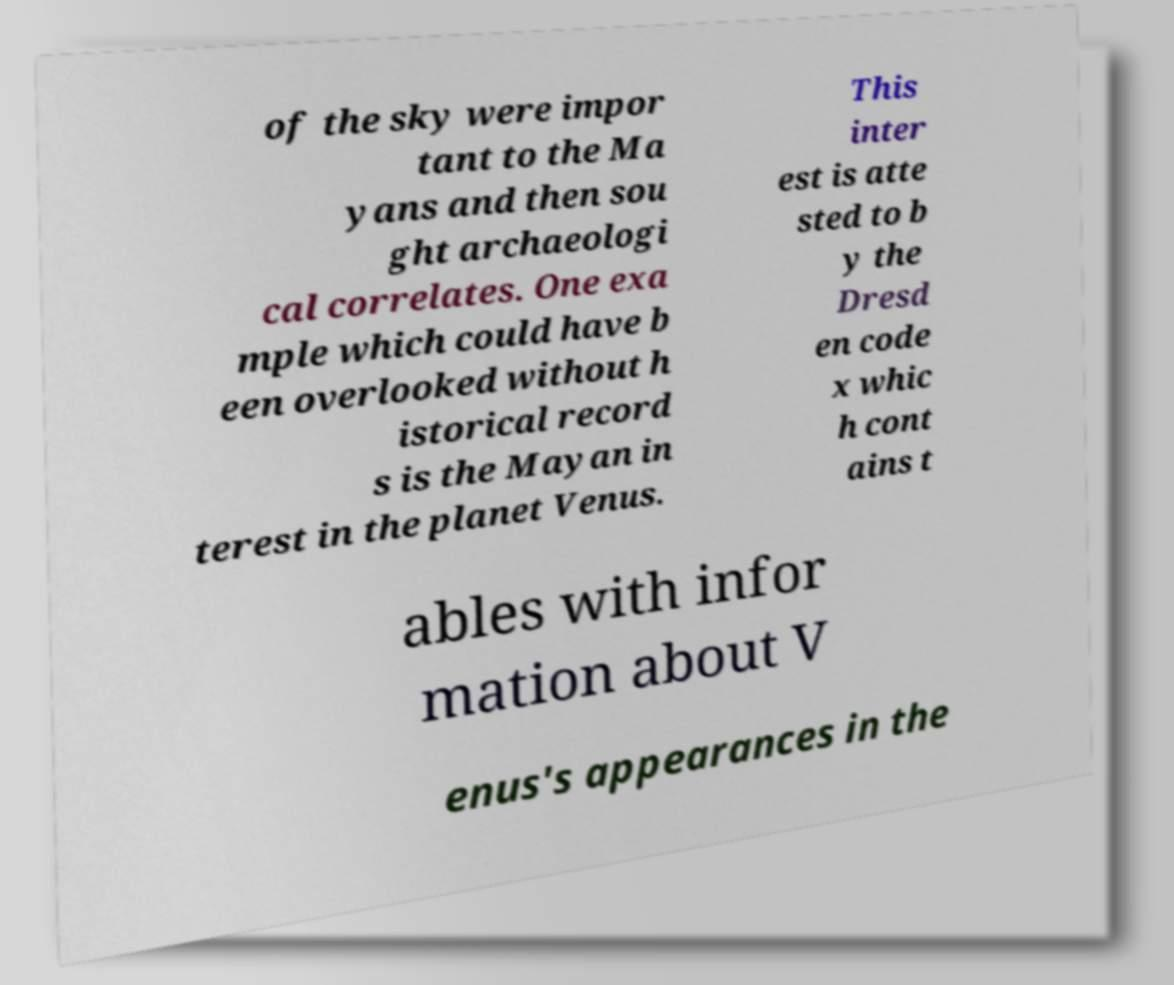For documentation purposes, I need the text within this image transcribed. Could you provide that? of the sky were impor tant to the Ma yans and then sou ght archaeologi cal correlates. One exa mple which could have b een overlooked without h istorical record s is the Mayan in terest in the planet Venus. This inter est is atte sted to b y the Dresd en code x whic h cont ains t ables with infor mation about V enus's appearances in the 